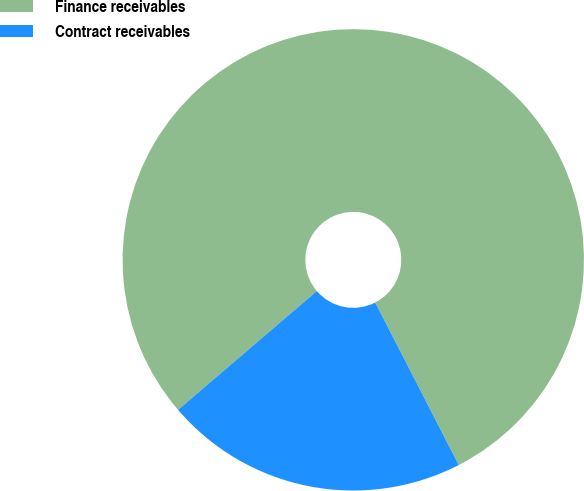Convert chart to OTSL. <chart><loc_0><loc_0><loc_500><loc_500><pie_chart><fcel>Finance receivables<fcel>Contract receivables<nl><fcel>78.71%<fcel>21.29%<nl></chart> 